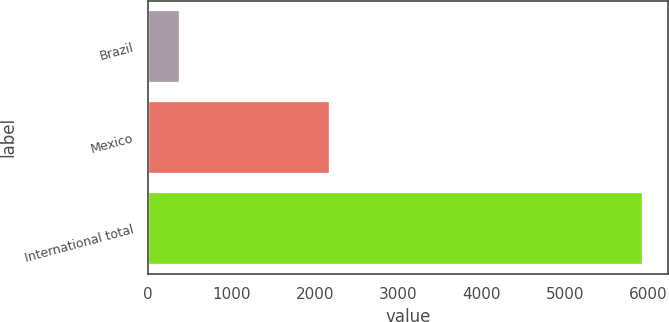Convert chart. <chart><loc_0><loc_0><loc_500><loc_500><bar_chart><fcel>Brazil<fcel>Mexico<fcel>International total<nl><fcel>380<fcel>2186<fcel>5945<nl></chart> 